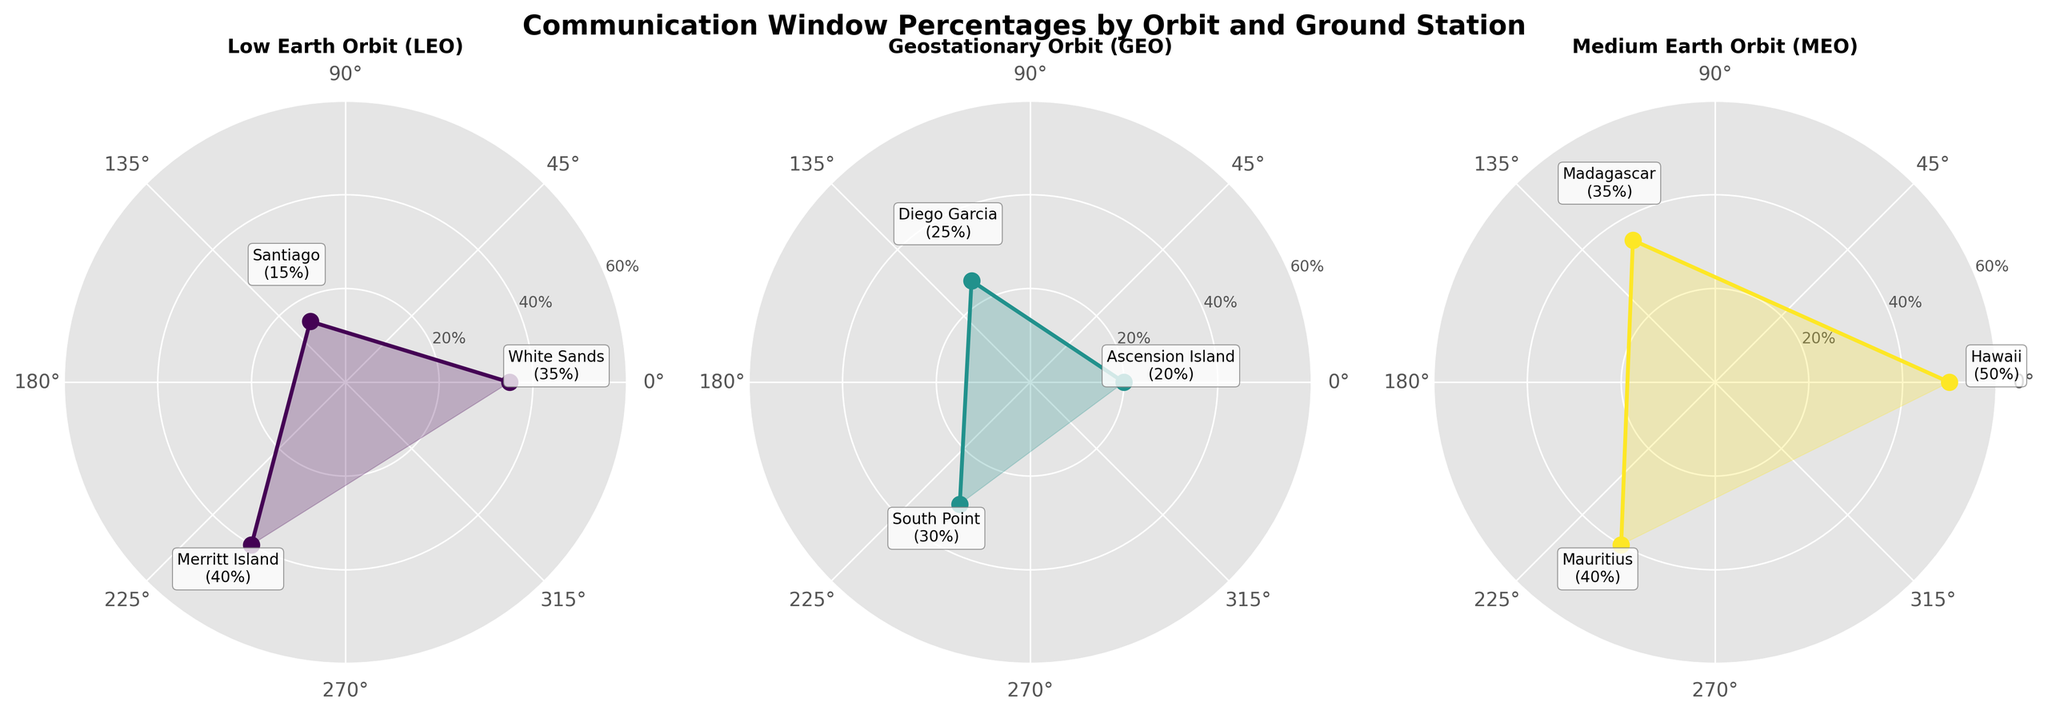What's the title of the figure? The title is located at the top of the figure, reading the text gives the answer.
Answer: Communication Window Percentages by Orbit and Ground Station Which orbit has the highest communication window percentage for Telemetry? By examining the charts, LEO shows 35% (White Sands), GEO shows 20% (Ascension Island), and MEO shows 50% (Hawaii); MEO has the highest.
Answer: Medium Earth Orbit (MEO) Compare the communication window percentages for the Downlink mission in LEO and GEO. Which one is higher? In LEO, it is 40% (Merritt Island) and in GEO, it is 30% (South Point). By comparing these percentages, LEO has a higher value.
Answer: LEO What is the average communication window percentage for all ground stations in GEO? Adding the percentages (20% + 25% + 30%) and dividing by 3 (number of ground stations) yields the average. (20 + 25 + 30) / 3 = 25%
Answer: 25% Which ground station has the lowest communication window percentage in LEO? In the LEO chart, the percentages for White Sands, Santiago, and Merritt Island are 35%, 15%, and 40% respectively. Santiago has the lowest percentage.
Answer: Santiago How does the communication window percentage of White Sands (LEO) compare to Hawaii (MEO)? White Sands has 35% and Hawaii has 50%. Comparing these, Hawaii has a higher percentage.
Answer: Hawaii has a higher percentage What is the total communication window percentage for all ground stations in MEO? Adding the percentages of the three stations in MEO: 50% (Hawaii), 35% (Madagascar), 40% (Mauritius). The sum is 50 + 35 + 40 = 125%.
Answer: 125% Is there any mission type with a communication window percentage of 15%? The Santiago (LEO) station shows a 15% communication window for the Command mission type.
Answer: Yes Which orbit type has the highest overall communication window percentage? Aggregating the percentages: LEO (35% + 15% + 40% = 90%), GEO (20% + 25% + 30% = 75%), MEO (50% + 35% + 40% = 125%). MEO has the highest total value.
Answer: MEO What is the range of communication window percentages for ground stations in GEO? In GEO, the lowest percentage is 20% (Ascension Island) and the highest is 30% (South Point), so the range is 30 - 20 = 10%.
Answer: 10% 